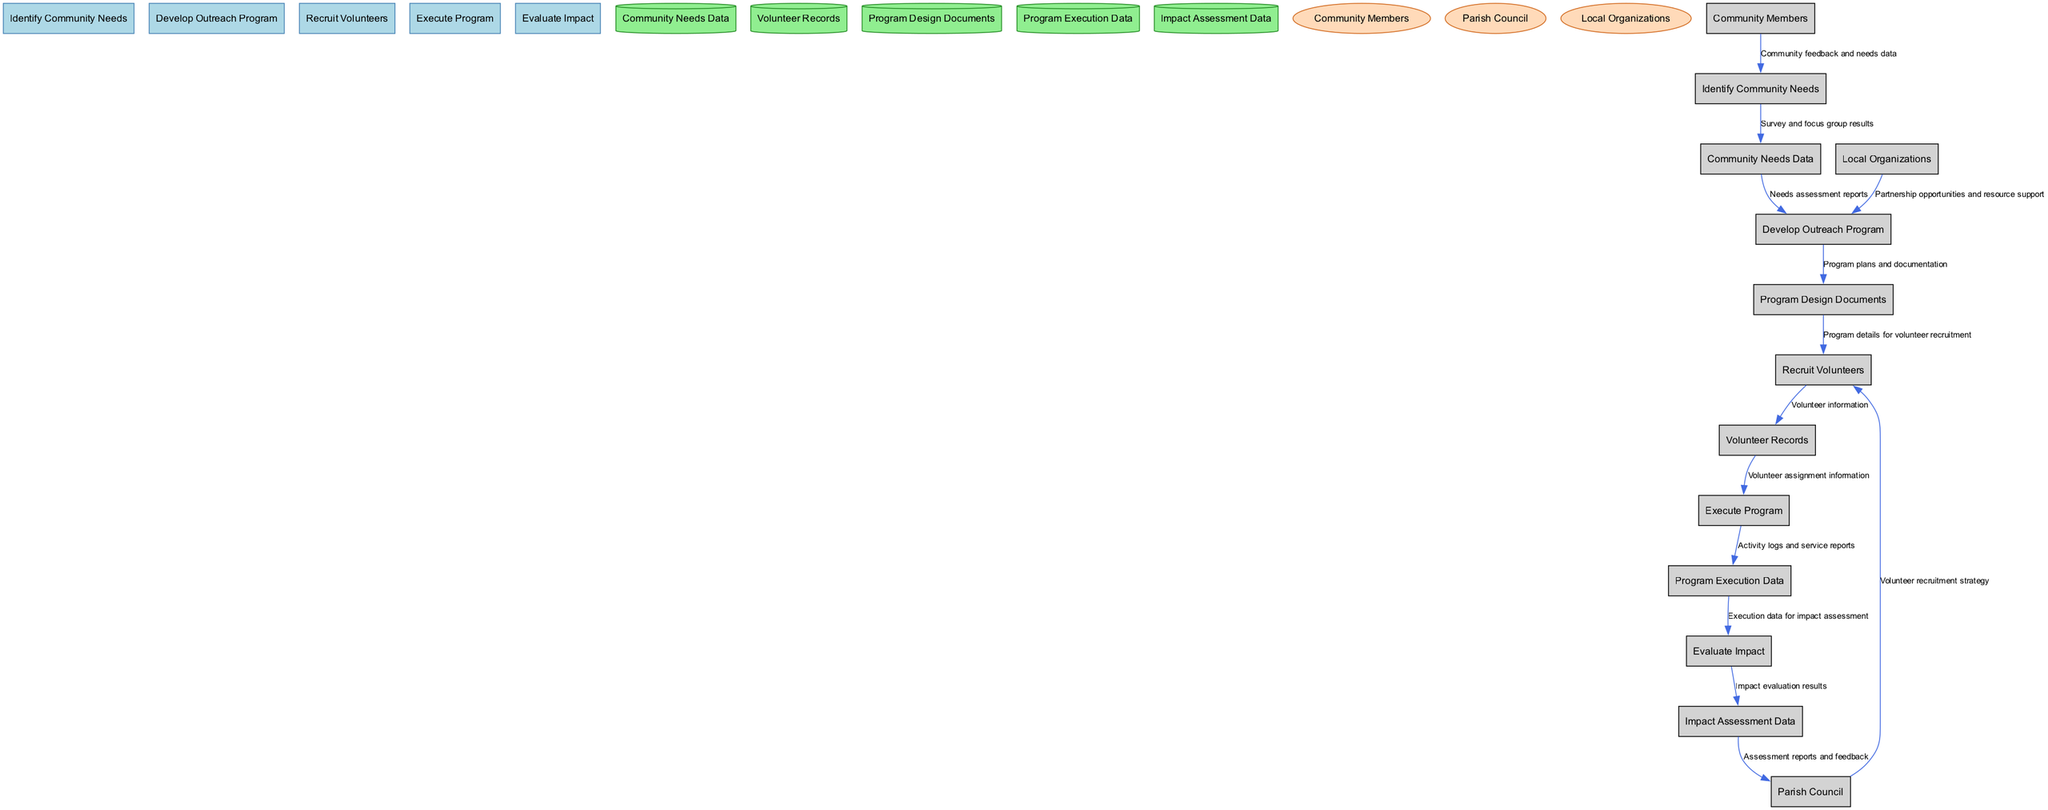What is the first process in the diagram? The first process listed in the diagram is "Identify Community Needs," as it is the first one mentioned in the processes section.
Answer: Identify Community Needs How many data stores are present in the diagram? The diagram lists five data stores: Community Needs Data, Volunteer Records, Program Design Documents, Program Execution Data, and Impact Assessment Data. Counting these gives a total of five data stores.
Answer: 5 What type of node is "Program Design Documents"? "Program Design Documents" is categorized as a data store in the diagram, specifically identified as a cylinder shape.
Answer: Data store Which entities provide input to the "Develop Outreach Program" process? The "Develop Outreach Program" process receives input from two sources: "Community Needs Data" and "Local Organizations." Combined, these inputs lead to the development of the outreach program.
Answer: Community Needs Data, Local Organizations What is the final output of the "Evaluate Impact" process? The final output of the "Evaluate Impact" process is the "Impact Assessment Data," which consists of the evaluation results from assessing the outreach program’s effectiveness.
Answer: Impact Assessment Data Which process follows "Recruit Volunteers"? The process that follows "Recruit Volunteers" in the flow is "Execute Program," where the outreach activities are carried out based on the volunteers recruited.
Answer: Execute Program Which external entity receives the reports from the "Evaluate Impact" process? The "Parish Council" is the external entity that receives the assessment reports and feedback originating from the "Evaluate Impact" process.
Answer: Parish Council How many edges connect to the "Execute Program" process? The "Execute Program" process has two edges connecting to it: one from "Volunteer Records" and another flowing to "Program Execution Data," indicating its receipt and output of information.
Answer: 2 What data flows are connected to "Community Needs Data"? Two data flows connect to "Community Needs Data": one from "Identify Community Needs" and one to "Develop Outreach Program," indicating its role as a central data store in the process.
Answer: 2 